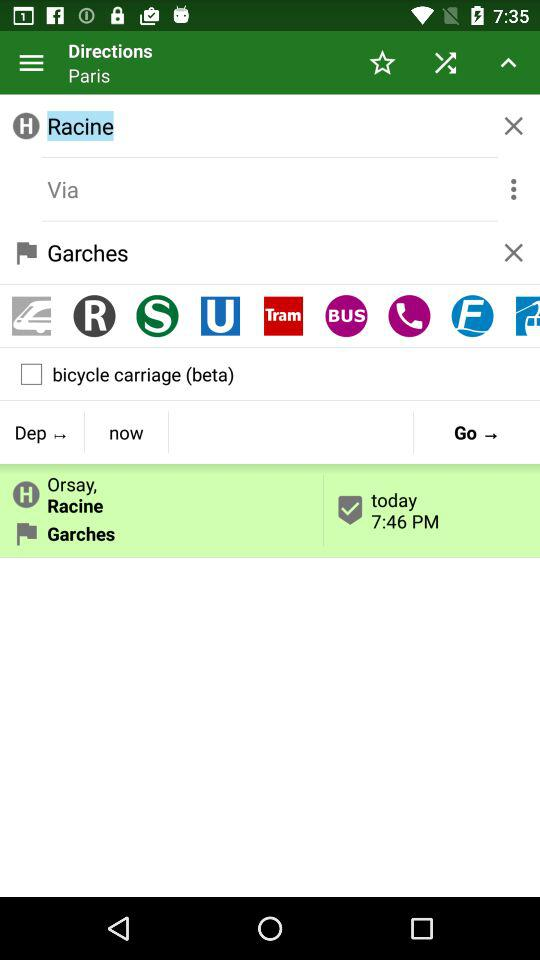What are the coordinates of the location displayed on the screen?
When the provided information is insufficient, respond with <no answer>. <no answer> 